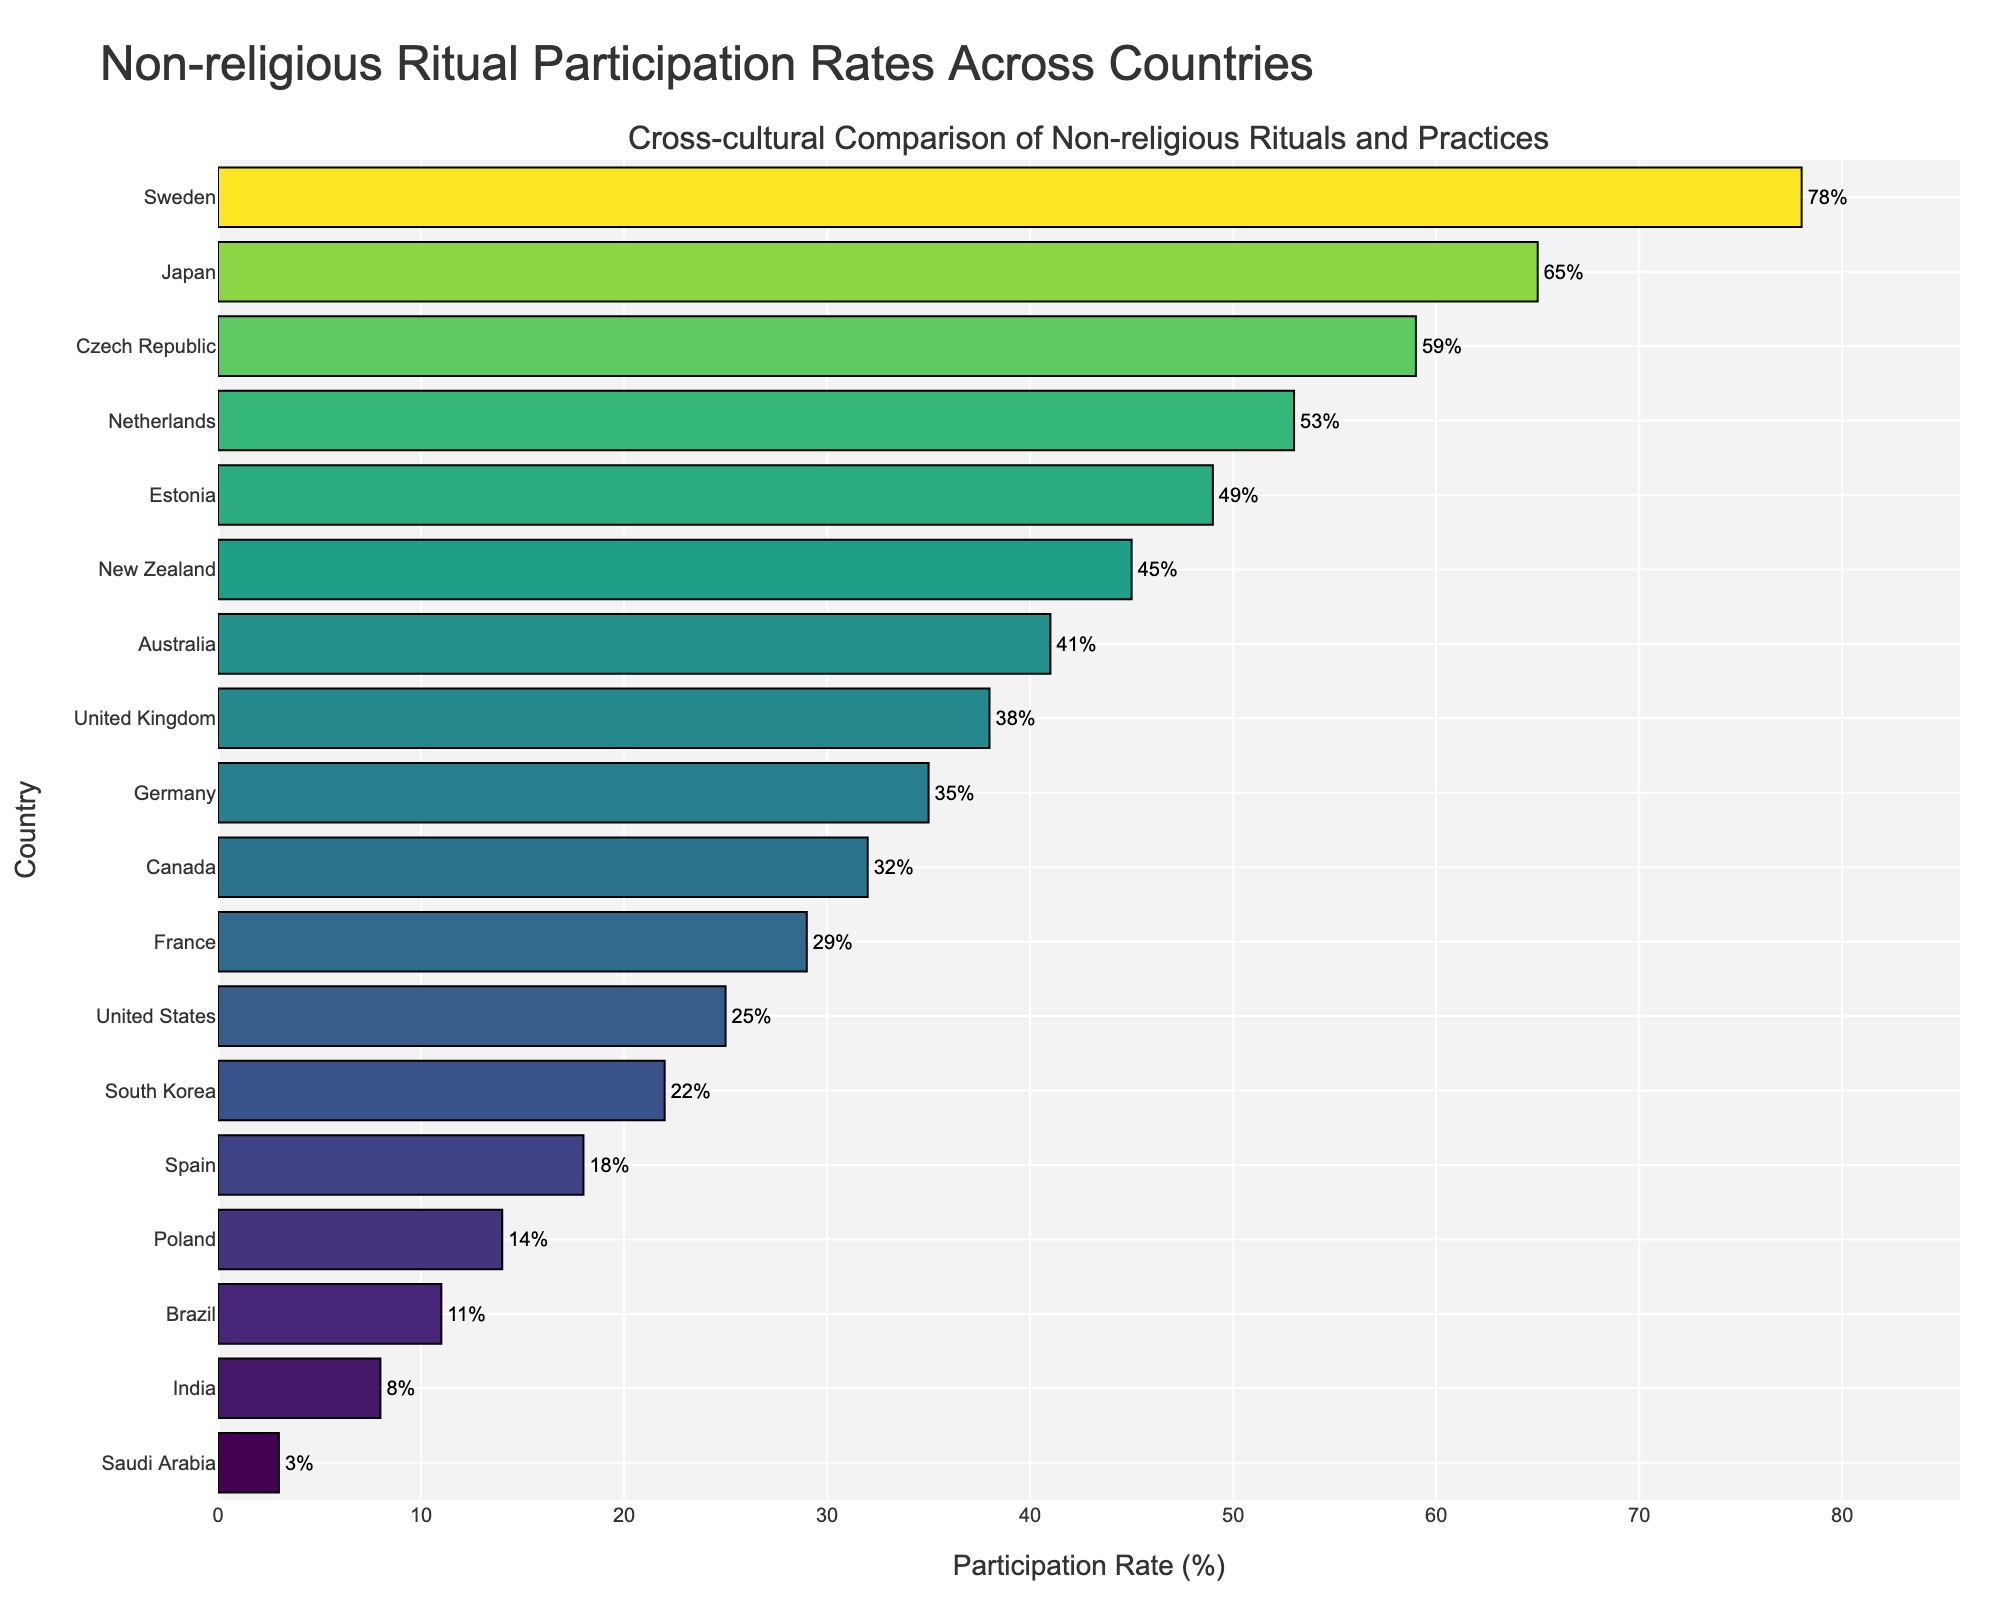Which country has the highest non-religious ritual participation rate? Sweden has the highest non-religious ritual participation rate, which is 78%. This can be seen as it is the topmost bar in the chart with the longest length.
Answer: Sweden Which country has the lowest non-religious ritual participation rate? Saudi Arabia has the lowest non-religious ritual participation rate, which is 3%. This can be observed as it is the bottommost bar in the chart with the shortest length.
Answer: Saudi Arabia How many countries have a non-religious ritual participation rate above 50%? To determine this, we count the bars that extend past the 50% mark. The countries above the 50% mark are Sweden, Japan, Czech Republic, and Netherlands.
Answer: 4 What is the difference in non-religious ritual participation rates between Sweden and Saudi Arabia? Sweden has a rate of 78%, while Saudi Arabia has a rate of 3%. The difference is 78% - 3% = 75%.
Answer: 75% Which countries have a non-religious ritual participation rate between 10% and 20%? By identifying the bars that fall within the 10%-20% range, we find that Spain and Poland meet this criterion with rates of 18% and 14%, respectively.
Answer: Spain and Poland Compare the participation rates of Germany and France, and indicate which country has a higher rate. Germany has a participation rate of 35% while France has a rate of 29%. Since 35% is greater than 29%, Germany has a higher rate.
Answer: Germany What is the average participation rate of all countries listed in the chart? Summing up the rates: 78 + 65 + 59 + 53 + 49 + 45 + 41 + 38 + 35 + 32 + 29 + 25 + 22 + 18 + 14 + 11 + 8 + 3 = 625. There are 18 countries, so the average rate is 625 / 18 ≈ 34.72%.
Answer: 34.72% Which country ranks fifth in non-religious ritual participation rate? By examining the fifth bar from the top in the chart, Estonia is seen to have the fifth highest participation rate of 49%.
Answer: Estonia Identify all countries with a non-religious ritual participation rate below 20%. To find these, we look for bars shorter than the 20% mark. The countries are Saudi Arabia, India, Brazil, Poland, and Spain with rates of 3%, 8%, 11%, 14%, and 18%, respectively.
Answer: Saudi Arabia, India, Brazil, Poland, Spain 